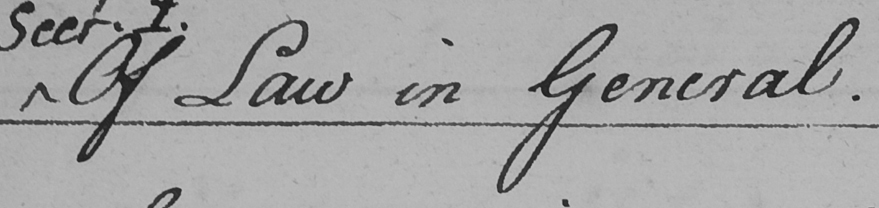Please transcribe the handwritten text in this image. Of Law in General . 